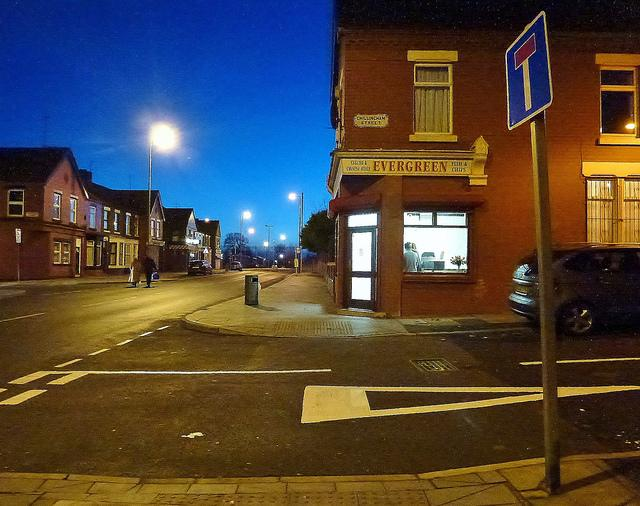What does the blue road sign warn of?

Choices:
A) intersection
B) deaf children
C) construction
D) child crossing intersection 